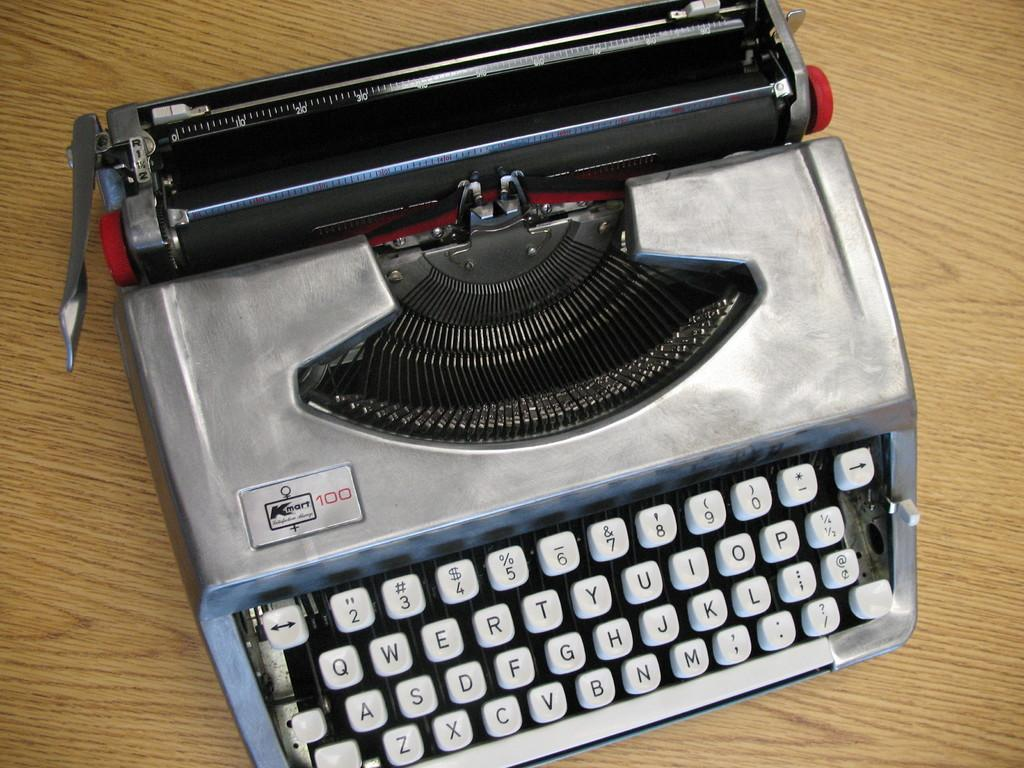<image>
Render a clear and concise summary of the photo. A Kmart 100 silver typewriter with red turning dials. 